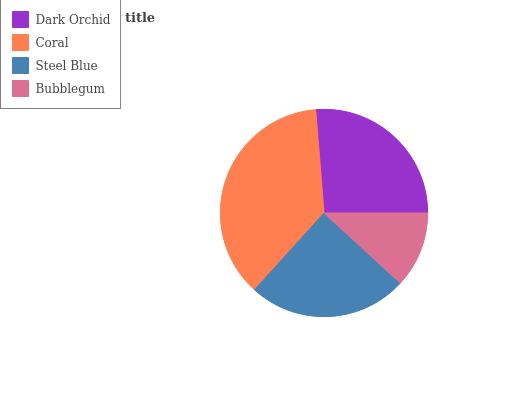Is Bubblegum the minimum?
Answer yes or no. Yes. Is Coral the maximum?
Answer yes or no. Yes. Is Steel Blue the minimum?
Answer yes or no. No. Is Steel Blue the maximum?
Answer yes or no. No. Is Coral greater than Steel Blue?
Answer yes or no. Yes. Is Steel Blue less than Coral?
Answer yes or no. Yes. Is Steel Blue greater than Coral?
Answer yes or no. No. Is Coral less than Steel Blue?
Answer yes or no. No. Is Dark Orchid the high median?
Answer yes or no. Yes. Is Steel Blue the low median?
Answer yes or no. Yes. Is Coral the high median?
Answer yes or no. No. Is Dark Orchid the low median?
Answer yes or no. No. 